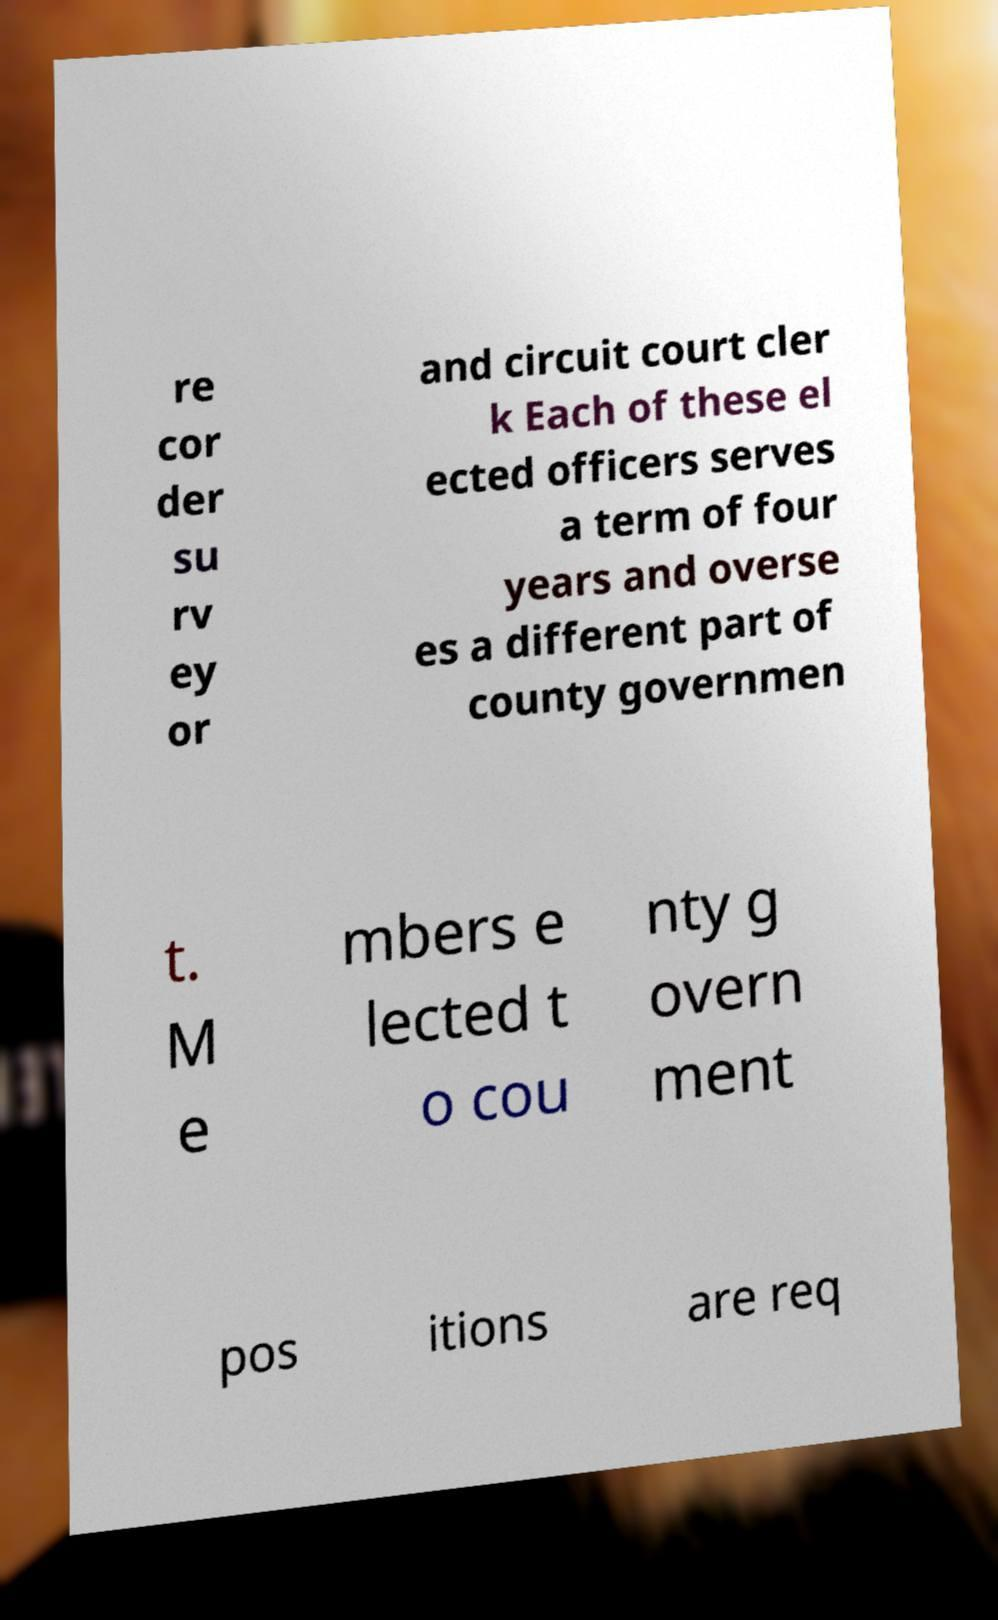Can you accurately transcribe the text from the provided image for me? re cor der su rv ey or and circuit court cler k Each of these el ected officers serves a term of four years and overse es a different part of county governmen t. M e mbers e lected t o cou nty g overn ment pos itions are req 